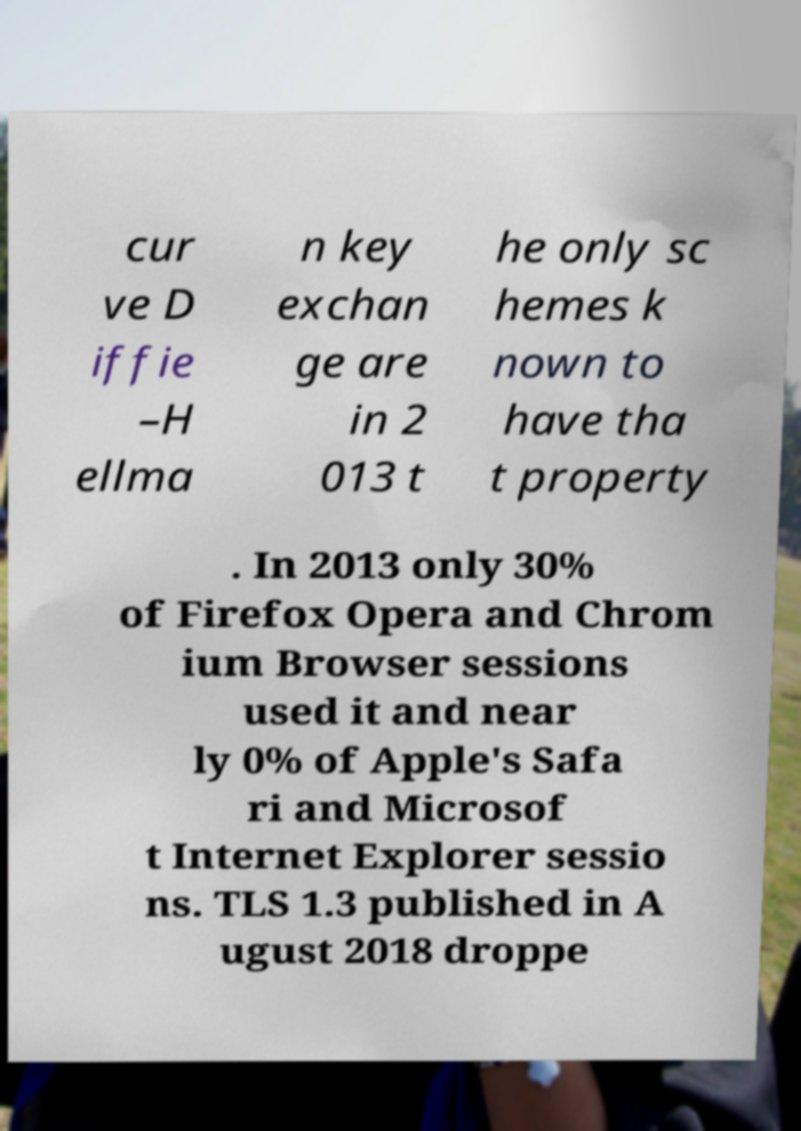Please read and relay the text visible in this image. What does it say? cur ve D iffie –H ellma n key exchan ge are in 2 013 t he only sc hemes k nown to have tha t property . In 2013 only 30% of Firefox Opera and Chrom ium Browser sessions used it and near ly 0% of Apple's Safa ri and Microsof t Internet Explorer sessio ns. TLS 1.3 published in A ugust 2018 droppe 